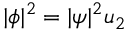<formula> <loc_0><loc_0><loc_500><loc_500>| \phi | ^ { 2 } = | \psi | ^ { 2 } u _ { 2 }</formula> 